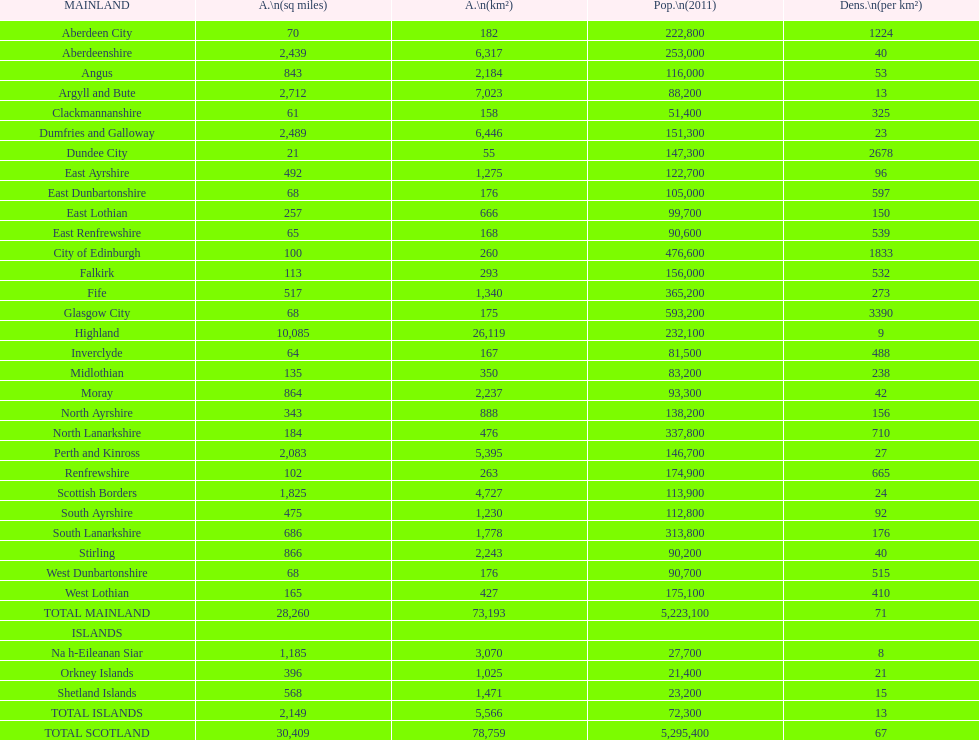What is the typical population density in cities located on the mainland? 71. Could you parse the entire table? {'header': ['MAINLAND', 'A.\\n(sq miles)', 'A.\\n(km²)', 'Pop.\\n(2011)', 'Dens.\\n(per km²)'], 'rows': [['Aberdeen City', '70', '182', '222,800', '1224'], ['Aberdeenshire', '2,439', '6,317', '253,000', '40'], ['Angus', '843', '2,184', '116,000', '53'], ['Argyll and Bute', '2,712', '7,023', '88,200', '13'], ['Clackmannanshire', '61', '158', '51,400', '325'], ['Dumfries and Galloway', '2,489', '6,446', '151,300', '23'], ['Dundee City', '21', '55', '147,300', '2678'], ['East Ayrshire', '492', '1,275', '122,700', '96'], ['East Dunbartonshire', '68', '176', '105,000', '597'], ['East Lothian', '257', '666', '99,700', '150'], ['East Renfrewshire', '65', '168', '90,600', '539'], ['City of Edinburgh', '100', '260', '476,600', '1833'], ['Falkirk', '113', '293', '156,000', '532'], ['Fife', '517', '1,340', '365,200', '273'], ['Glasgow City', '68', '175', '593,200', '3390'], ['Highland', '10,085', '26,119', '232,100', '9'], ['Inverclyde', '64', '167', '81,500', '488'], ['Midlothian', '135', '350', '83,200', '238'], ['Moray', '864', '2,237', '93,300', '42'], ['North Ayrshire', '343', '888', '138,200', '156'], ['North Lanarkshire', '184', '476', '337,800', '710'], ['Perth and Kinross', '2,083', '5,395', '146,700', '27'], ['Renfrewshire', '102', '263', '174,900', '665'], ['Scottish Borders', '1,825', '4,727', '113,900', '24'], ['South Ayrshire', '475', '1,230', '112,800', '92'], ['South Lanarkshire', '686', '1,778', '313,800', '176'], ['Stirling', '866', '2,243', '90,200', '40'], ['West Dunbartonshire', '68', '176', '90,700', '515'], ['West Lothian', '165', '427', '175,100', '410'], ['TOTAL MAINLAND', '28,260', '73,193', '5,223,100', '71'], ['ISLANDS', '', '', '', ''], ['Na h-Eileanan Siar', '1,185', '3,070', '27,700', '8'], ['Orkney Islands', '396', '1,025', '21,400', '21'], ['Shetland Islands', '568', '1,471', '23,200', '15'], ['TOTAL ISLANDS', '2,149', '5,566', '72,300', '13'], ['TOTAL SCOTLAND', '30,409', '78,759', '5,295,400', '67']]} 